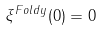Convert formula to latex. <formula><loc_0><loc_0><loc_500><loc_500>\xi ^ { F o l d y } ( 0 ) = 0</formula> 